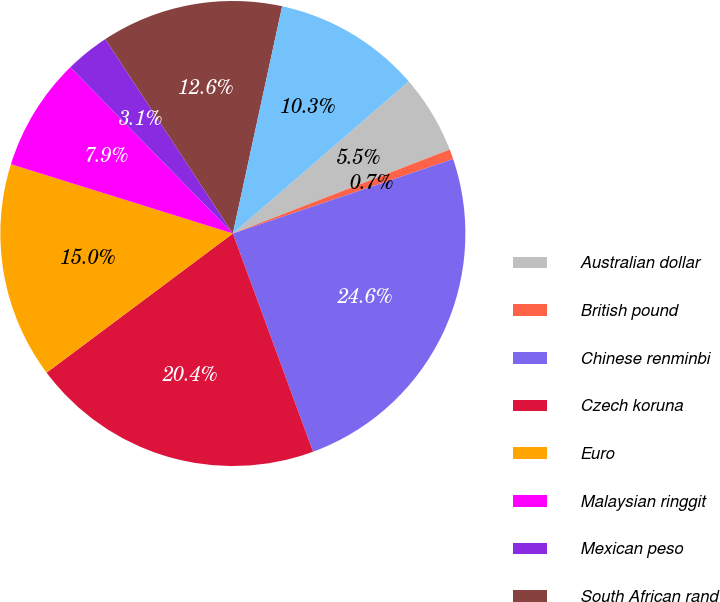<chart> <loc_0><loc_0><loc_500><loc_500><pie_chart><fcel>Australian dollar<fcel>British pound<fcel>Chinese renminbi<fcel>Czech koruna<fcel>Euro<fcel>Malaysian ringgit<fcel>Mexican peso<fcel>South African rand<fcel>United States dollar<nl><fcel>5.47%<fcel>0.69%<fcel>24.58%<fcel>20.39%<fcel>15.03%<fcel>7.86%<fcel>3.08%<fcel>12.64%<fcel>10.25%<nl></chart> 